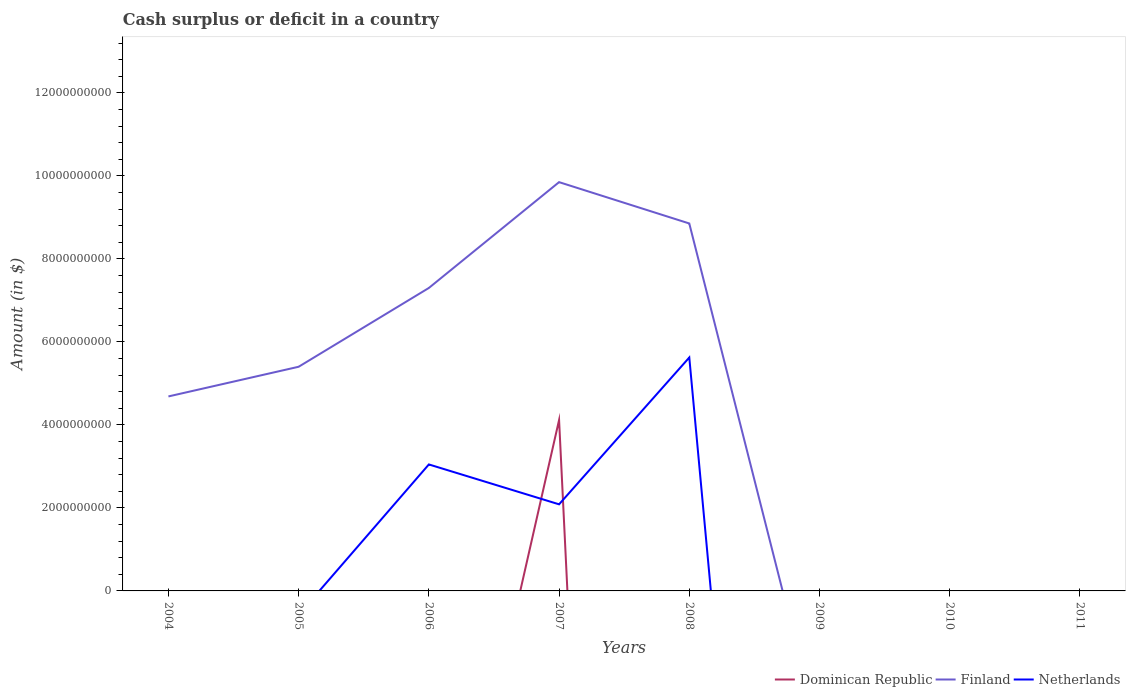How many different coloured lines are there?
Make the answer very short. 3. Does the line corresponding to Finland intersect with the line corresponding to Dominican Republic?
Keep it short and to the point. No. Across all years, what is the maximum amount of cash surplus or deficit in Finland?
Make the answer very short. 0. What is the total amount of cash surplus or deficit in Finland in the graph?
Offer a very short reply. -2.61e+09. What is the difference between the highest and the second highest amount of cash surplus or deficit in Netherlands?
Provide a short and direct response. 5.62e+09. What is the difference between the highest and the lowest amount of cash surplus or deficit in Finland?
Your answer should be compact. 5. How many years are there in the graph?
Your answer should be very brief. 8. Are the values on the major ticks of Y-axis written in scientific E-notation?
Your answer should be very brief. No. Does the graph contain any zero values?
Ensure brevity in your answer.  Yes. Does the graph contain grids?
Offer a very short reply. No. What is the title of the graph?
Make the answer very short. Cash surplus or deficit in a country. Does "Denmark" appear as one of the legend labels in the graph?
Offer a very short reply. No. What is the label or title of the Y-axis?
Provide a succinct answer. Amount (in $). What is the Amount (in $) in Dominican Republic in 2004?
Ensure brevity in your answer.  0. What is the Amount (in $) in Finland in 2004?
Keep it short and to the point. 4.69e+09. What is the Amount (in $) in Dominican Republic in 2005?
Keep it short and to the point. 0. What is the Amount (in $) in Finland in 2005?
Provide a succinct answer. 5.40e+09. What is the Amount (in $) of Dominican Republic in 2006?
Your response must be concise. 0. What is the Amount (in $) in Finland in 2006?
Ensure brevity in your answer.  7.30e+09. What is the Amount (in $) in Netherlands in 2006?
Provide a succinct answer. 3.05e+09. What is the Amount (in $) in Dominican Republic in 2007?
Give a very brief answer. 4.12e+09. What is the Amount (in $) in Finland in 2007?
Make the answer very short. 9.85e+09. What is the Amount (in $) in Netherlands in 2007?
Make the answer very short. 2.09e+09. What is the Amount (in $) in Dominican Republic in 2008?
Provide a short and direct response. 0. What is the Amount (in $) in Finland in 2008?
Your answer should be compact. 8.86e+09. What is the Amount (in $) in Netherlands in 2008?
Make the answer very short. 5.62e+09. What is the Amount (in $) of Dominican Republic in 2009?
Your answer should be compact. 0. What is the Amount (in $) of Finland in 2009?
Your answer should be very brief. 0. What is the Amount (in $) in Netherlands in 2009?
Offer a very short reply. 0. What is the Amount (in $) in Finland in 2010?
Provide a succinct answer. 0. What is the Amount (in $) of Dominican Republic in 2011?
Give a very brief answer. 0. What is the Amount (in $) in Finland in 2011?
Offer a very short reply. 0. Across all years, what is the maximum Amount (in $) in Dominican Republic?
Provide a short and direct response. 4.12e+09. Across all years, what is the maximum Amount (in $) in Finland?
Your response must be concise. 9.85e+09. Across all years, what is the maximum Amount (in $) of Netherlands?
Offer a very short reply. 5.62e+09. Across all years, what is the minimum Amount (in $) of Finland?
Make the answer very short. 0. What is the total Amount (in $) of Dominican Republic in the graph?
Provide a short and direct response. 4.12e+09. What is the total Amount (in $) in Finland in the graph?
Offer a terse response. 3.61e+1. What is the total Amount (in $) in Netherlands in the graph?
Offer a terse response. 1.08e+1. What is the difference between the Amount (in $) in Finland in 2004 and that in 2005?
Offer a very short reply. -7.15e+08. What is the difference between the Amount (in $) of Finland in 2004 and that in 2006?
Make the answer very short. -2.61e+09. What is the difference between the Amount (in $) of Finland in 2004 and that in 2007?
Your answer should be very brief. -5.16e+09. What is the difference between the Amount (in $) in Finland in 2004 and that in 2008?
Provide a succinct answer. -4.17e+09. What is the difference between the Amount (in $) of Finland in 2005 and that in 2006?
Ensure brevity in your answer.  -1.90e+09. What is the difference between the Amount (in $) of Finland in 2005 and that in 2007?
Keep it short and to the point. -4.45e+09. What is the difference between the Amount (in $) of Finland in 2005 and that in 2008?
Offer a very short reply. -3.45e+09. What is the difference between the Amount (in $) of Finland in 2006 and that in 2007?
Provide a short and direct response. -2.55e+09. What is the difference between the Amount (in $) of Netherlands in 2006 and that in 2007?
Provide a succinct answer. 9.61e+08. What is the difference between the Amount (in $) in Finland in 2006 and that in 2008?
Ensure brevity in your answer.  -1.55e+09. What is the difference between the Amount (in $) in Netherlands in 2006 and that in 2008?
Your answer should be very brief. -2.58e+09. What is the difference between the Amount (in $) of Finland in 2007 and that in 2008?
Your answer should be very brief. 9.96e+08. What is the difference between the Amount (in $) in Netherlands in 2007 and that in 2008?
Your answer should be compact. -3.54e+09. What is the difference between the Amount (in $) in Finland in 2004 and the Amount (in $) in Netherlands in 2006?
Your response must be concise. 1.64e+09. What is the difference between the Amount (in $) in Finland in 2004 and the Amount (in $) in Netherlands in 2007?
Offer a terse response. 2.60e+09. What is the difference between the Amount (in $) of Finland in 2004 and the Amount (in $) of Netherlands in 2008?
Offer a very short reply. -9.38e+08. What is the difference between the Amount (in $) in Finland in 2005 and the Amount (in $) in Netherlands in 2006?
Offer a very short reply. 2.35e+09. What is the difference between the Amount (in $) of Finland in 2005 and the Amount (in $) of Netherlands in 2007?
Offer a very short reply. 3.32e+09. What is the difference between the Amount (in $) in Finland in 2005 and the Amount (in $) in Netherlands in 2008?
Make the answer very short. -2.23e+08. What is the difference between the Amount (in $) in Finland in 2006 and the Amount (in $) in Netherlands in 2007?
Your answer should be very brief. 5.21e+09. What is the difference between the Amount (in $) in Finland in 2006 and the Amount (in $) in Netherlands in 2008?
Your answer should be very brief. 1.68e+09. What is the difference between the Amount (in $) in Dominican Republic in 2007 and the Amount (in $) in Finland in 2008?
Provide a succinct answer. -4.74e+09. What is the difference between the Amount (in $) in Dominican Republic in 2007 and the Amount (in $) in Netherlands in 2008?
Your response must be concise. -1.51e+09. What is the difference between the Amount (in $) in Finland in 2007 and the Amount (in $) in Netherlands in 2008?
Keep it short and to the point. 4.23e+09. What is the average Amount (in $) of Dominican Republic per year?
Ensure brevity in your answer.  5.15e+08. What is the average Amount (in $) of Finland per year?
Provide a short and direct response. 4.51e+09. What is the average Amount (in $) in Netherlands per year?
Offer a terse response. 1.34e+09. In the year 2006, what is the difference between the Amount (in $) in Finland and Amount (in $) in Netherlands?
Your answer should be compact. 4.25e+09. In the year 2007, what is the difference between the Amount (in $) in Dominican Republic and Amount (in $) in Finland?
Make the answer very short. -5.73e+09. In the year 2007, what is the difference between the Amount (in $) of Dominican Republic and Amount (in $) of Netherlands?
Your answer should be compact. 2.03e+09. In the year 2007, what is the difference between the Amount (in $) in Finland and Amount (in $) in Netherlands?
Make the answer very short. 7.76e+09. In the year 2008, what is the difference between the Amount (in $) of Finland and Amount (in $) of Netherlands?
Offer a terse response. 3.23e+09. What is the ratio of the Amount (in $) in Finland in 2004 to that in 2005?
Offer a very short reply. 0.87. What is the ratio of the Amount (in $) in Finland in 2004 to that in 2006?
Give a very brief answer. 0.64. What is the ratio of the Amount (in $) in Finland in 2004 to that in 2007?
Keep it short and to the point. 0.48. What is the ratio of the Amount (in $) in Finland in 2004 to that in 2008?
Provide a succinct answer. 0.53. What is the ratio of the Amount (in $) in Finland in 2005 to that in 2006?
Your answer should be compact. 0.74. What is the ratio of the Amount (in $) of Finland in 2005 to that in 2007?
Offer a terse response. 0.55. What is the ratio of the Amount (in $) in Finland in 2005 to that in 2008?
Make the answer very short. 0.61. What is the ratio of the Amount (in $) in Finland in 2006 to that in 2007?
Ensure brevity in your answer.  0.74. What is the ratio of the Amount (in $) in Netherlands in 2006 to that in 2007?
Keep it short and to the point. 1.46. What is the ratio of the Amount (in $) of Finland in 2006 to that in 2008?
Ensure brevity in your answer.  0.82. What is the ratio of the Amount (in $) of Netherlands in 2006 to that in 2008?
Your answer should be very brief. 0.54. What is the ratio of the Amount (in $) in Finland in 2007 to that in 2008?
Provide a short and direct response. 1.11. What is the ratio of the Amount (in $) of Netherlands in 2007 to that in 2008?
Your response must be concise. 0.37. What is the difference between the highest and the second highest Amount (in $) of Finland?
Make the answer very short. 9.96e+08. What is the difference between the highest and the second highest Amount (in $) in Netherlands?
Provide a succinct answer. 2.58e+09. What is the difference between the highest and the lowest Amount (in $) of Dominican Republic?
Provide a short and direct response. 4.12e+09. What is the difference between the highest and the lowest Amount (in $) in Finland?
Offer a terse response. 9.85e+09. What is the difference between the highest and the lowest Amount (in $) of Netherlands?
Your response must be concise. 5.62e+09. 